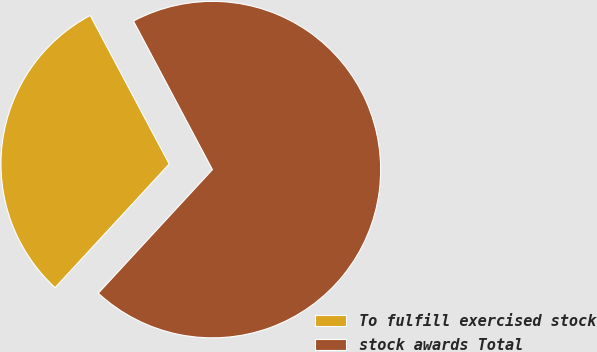Convert chart. <chart><loc_0><loc_0><loc_500><loc_500><pie_chart><fcel>To fulfill exercised stock<fcel>stock awards Total<nl><fcel>30.36%<fcel>69.64%<nl></chart> 